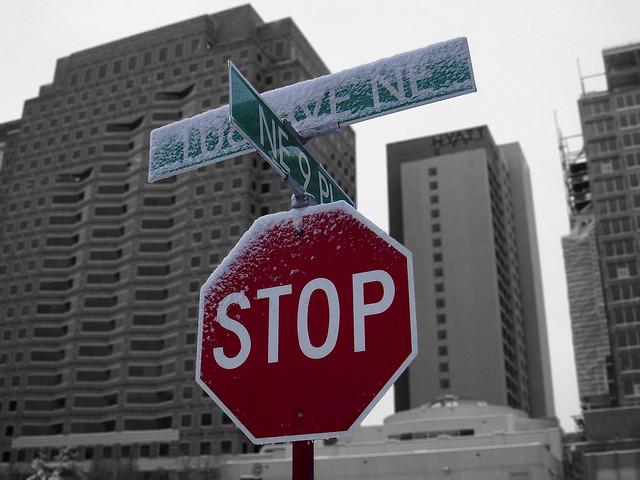Can pedestrians walk safely right now?
Short answer required. No. What does the sign say?
Keep it brief. Stop. What is the intersection?
Concise answer only. Ne 9 pl. Is this in the city or the country?
Write a very short answer. City. 